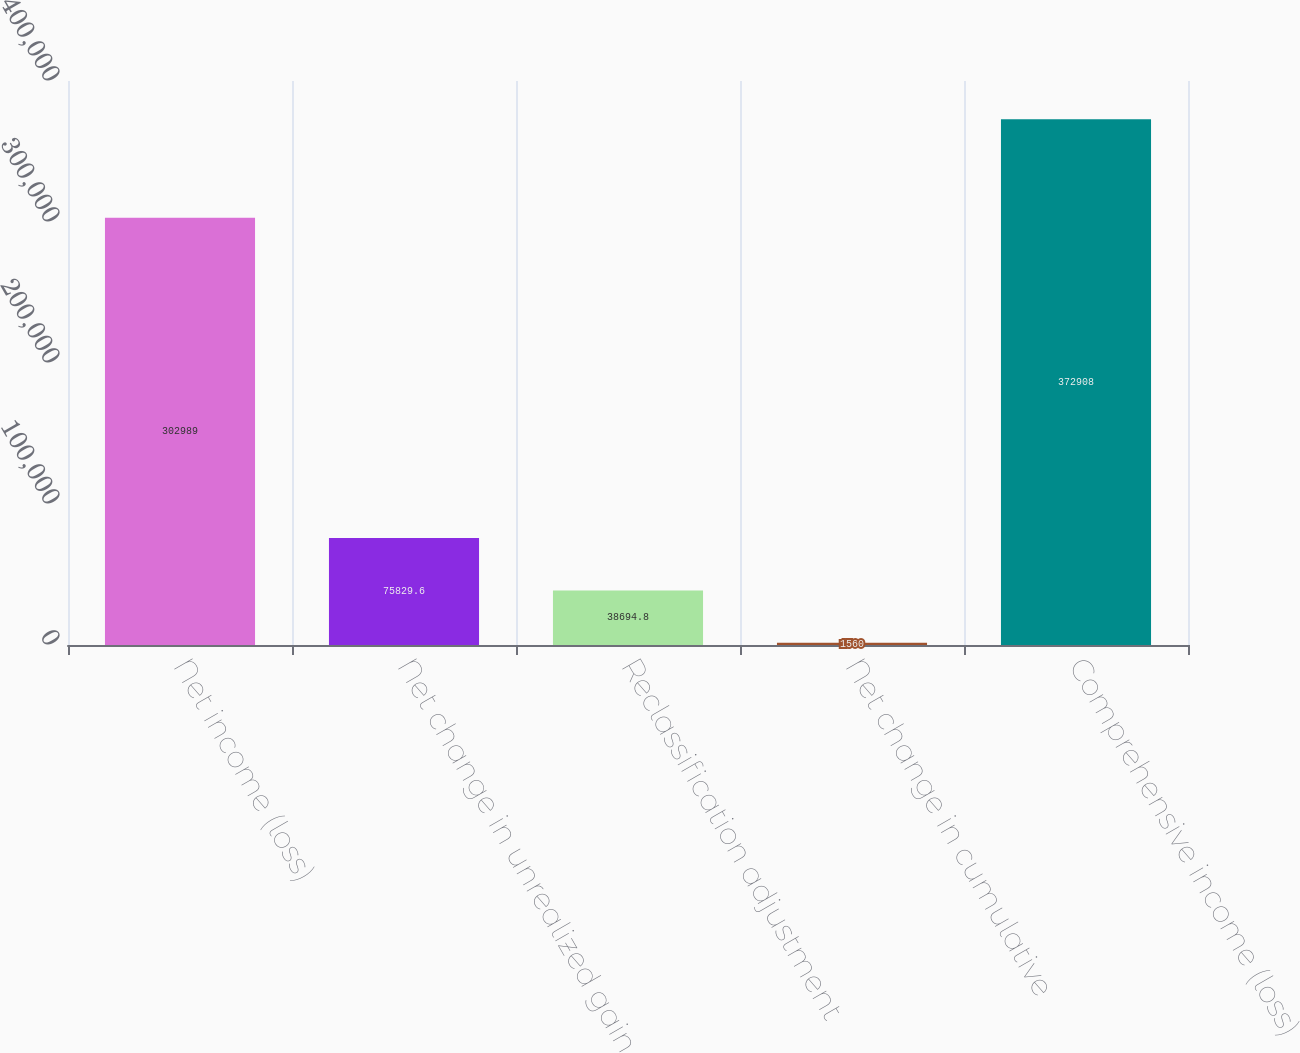<chart> <loc_0><loc_0><loc_500><loc_500><bar_chart><fcel>Net income (loss)<fcel>Net change in unrealized gain<fcel>Reclassification adjustment<fcel>Net change in cumulative<fcel>Comprehensive income (loss)<nl><fcel>302989<fcel>75829.6<fcel>38694.8<fcel>1560<fcel>372908<nl></chart> 